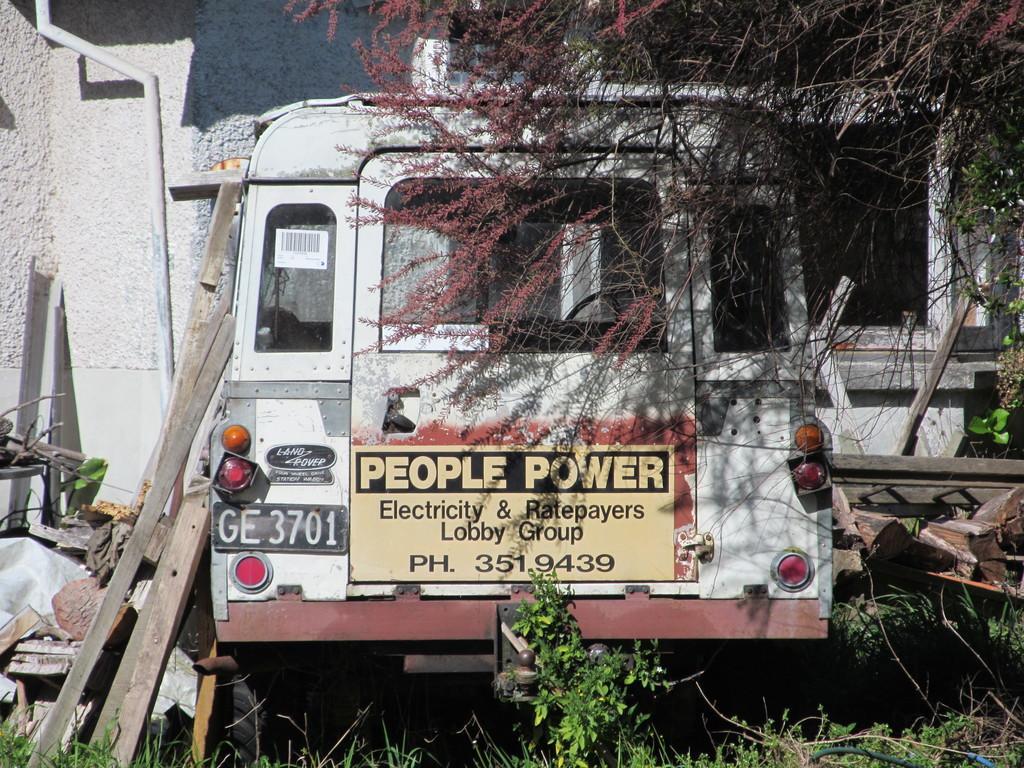Could you give a brief overview of what you see in this image? This picture is clicked outside. In the center there is a vehicle and we can see the text and numbers on the vehicle. In the foreground we can see the plants and some wooden objects. In the background there is a building and we can see the window of a building and we can see the trees and a metal rod. 